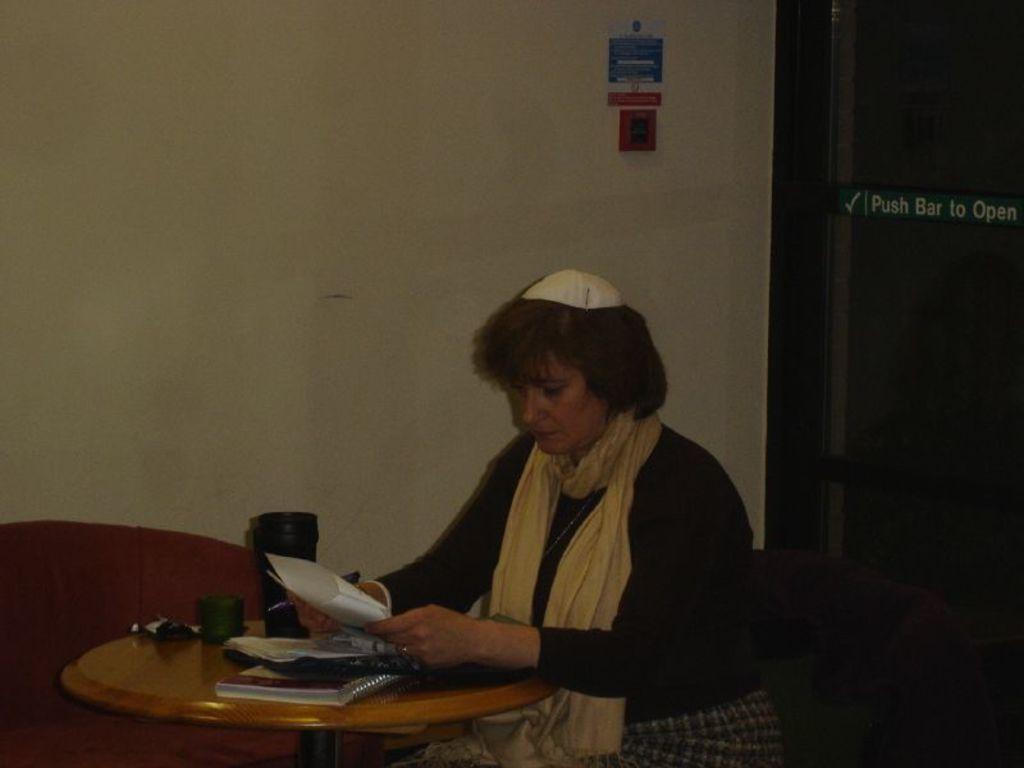Could you give a brief overview of what you see in this image? In this image I can see a woman is holding a paper and a pen. On this table I can see a book and few more stuffs. 